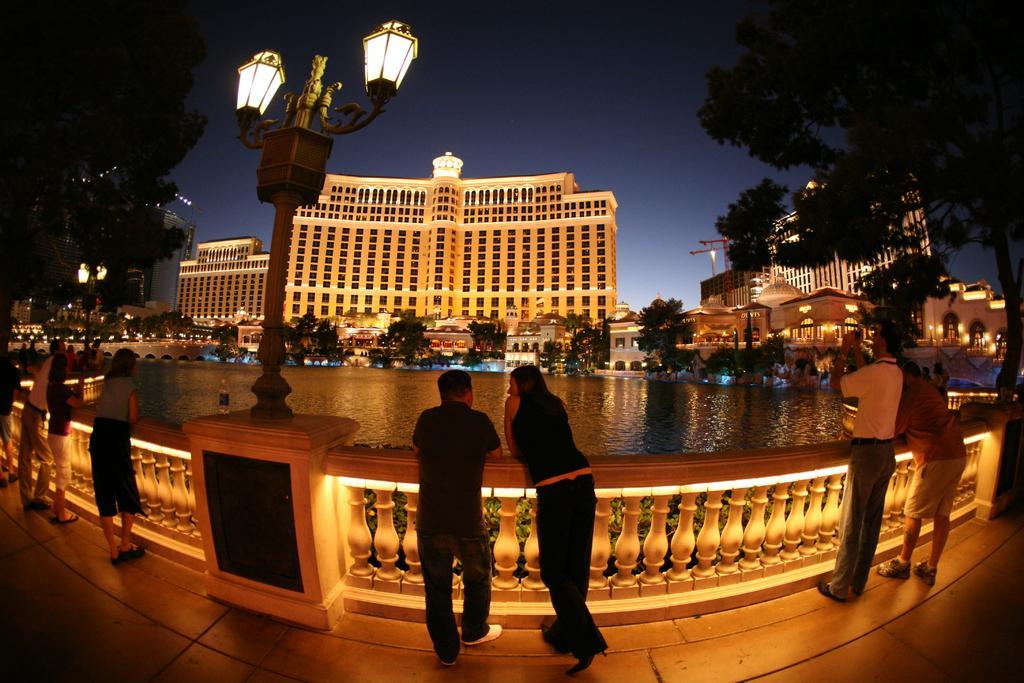Could you give a brief overview of what you see in this image? In the center of the image we can see the persons standing at the lake. On the right side of the image we can see tree and persons standing at the lake. On the left side of the image we can see light pole and persons standing at the lake. In the background there is a water, trees, buildings and sky. 